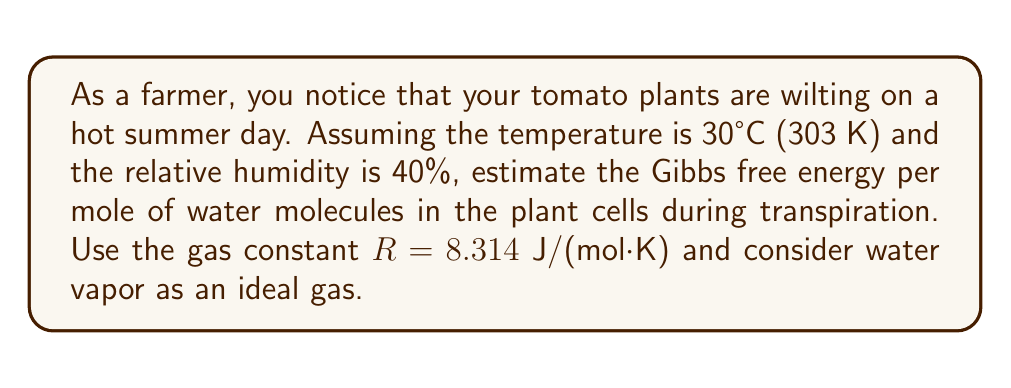What is the answer to this math problem? To estimate the Gibbs free energy of water molecules in plant cells during transpiration, we'll use the concept of chemical potential and the properties of an ideal gas. Here's a step-by-step approach:

1. The chemical potential of water vapor (μ) is related to its partial pressure (p) by:

   $$\mu = \mu_0 + RT \ln\left(\frac{p}{p_0}\right)$$

   where μ₀ is the chemical potential at standard pressure p₀ (1 atm).

2. The difference in chemical potential between liquid water in the plant cells and water vapor in the air is the Gibbs free energy change (ΔG) per mole of water:

   $$\Delta G = RT \ln\left(\frac{p}{p_0}\right)$$

3. At 100% relative humidity, p = p₀ (saturation vapor pressure). At 40% relative humidity:

   $$p = 0.4 \cdot p_0$$

4. Substituting this into our equation:

   $$\Delta G = RT \ln(0.4)$$

5. Now, let's plug in our values:
   R = 8.314 J/(mol·K)
   T = 303 K

   $$\Delta G = 8.314 \cdot 303 \cdot \ln(0.4)$$

6. Calculating:

   $$\Delta G = 2519.142 \cdot (-0.916290732) = -2308.23 \text{ J/mol}$$

This negative value indicates that water molecules spontaneously move from the plant cells to the air during transpiration.
Answer: $-2308$ J/mol 